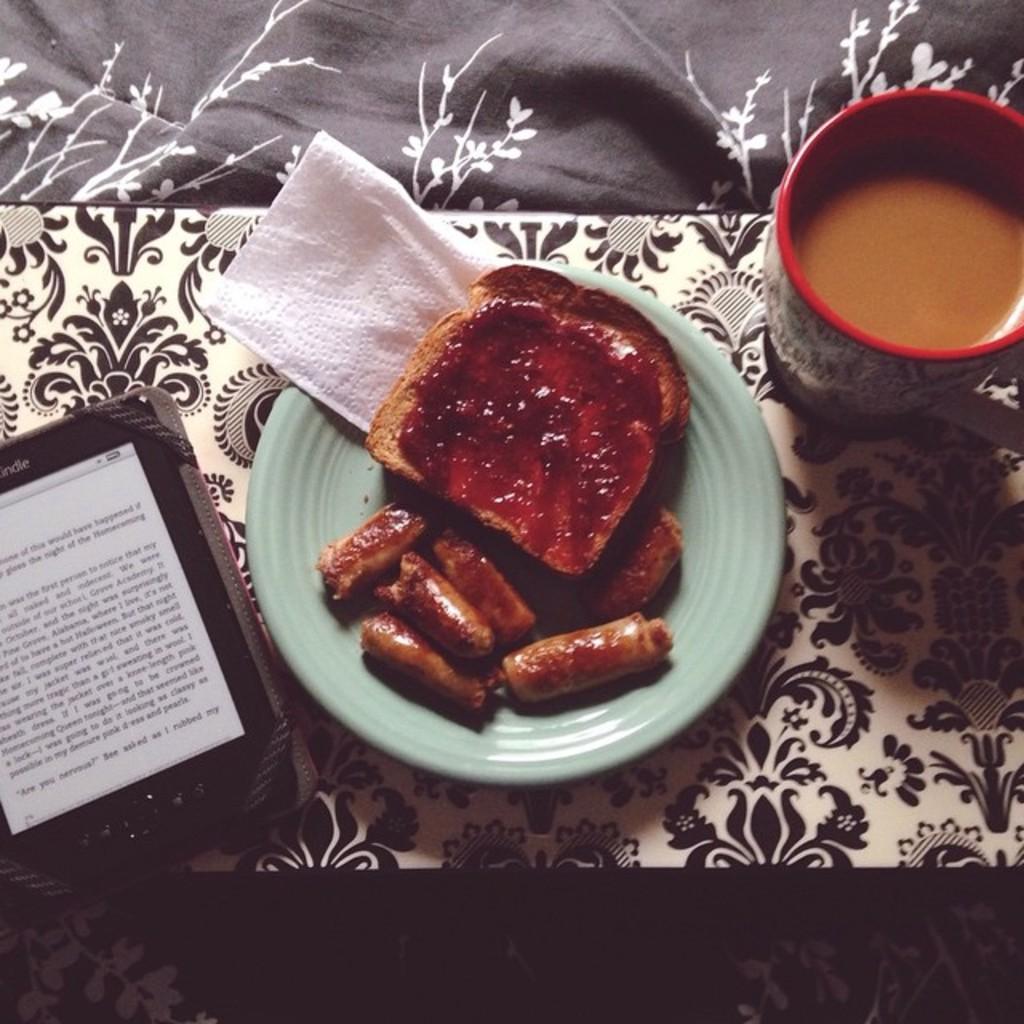What is the name of this device?
Your answer should be compact. Kindle. What do you do with that device?
Provide a succinct answer. Answering does not require reading text in the image. 